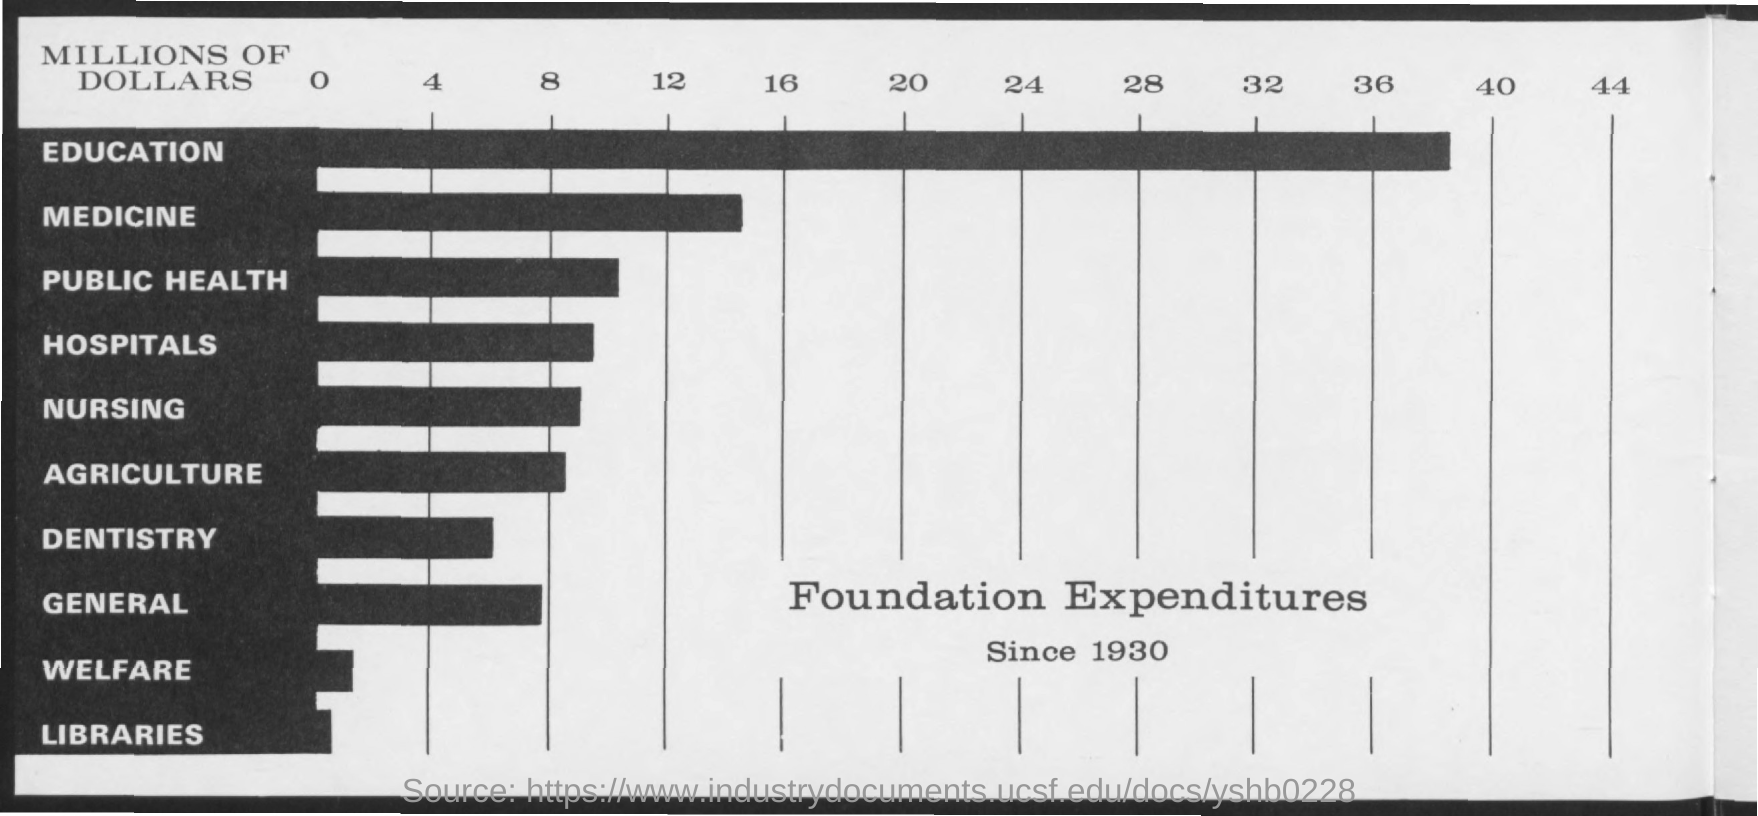Highlight a few significant elements in this photo. For which entry "Foundation Expenditure" is the second highest, specifically for the category of medicine? The expenditure is highest in the education segment. The maximum amount of expenditure for education as a percentage of foundation funding is depicted in the chart. The maximum value of "MILLIONS OF DOLLARS" mentioned on the graph is 44. Foundation expenditure is the minimum amount that should be allocated for libraries. 